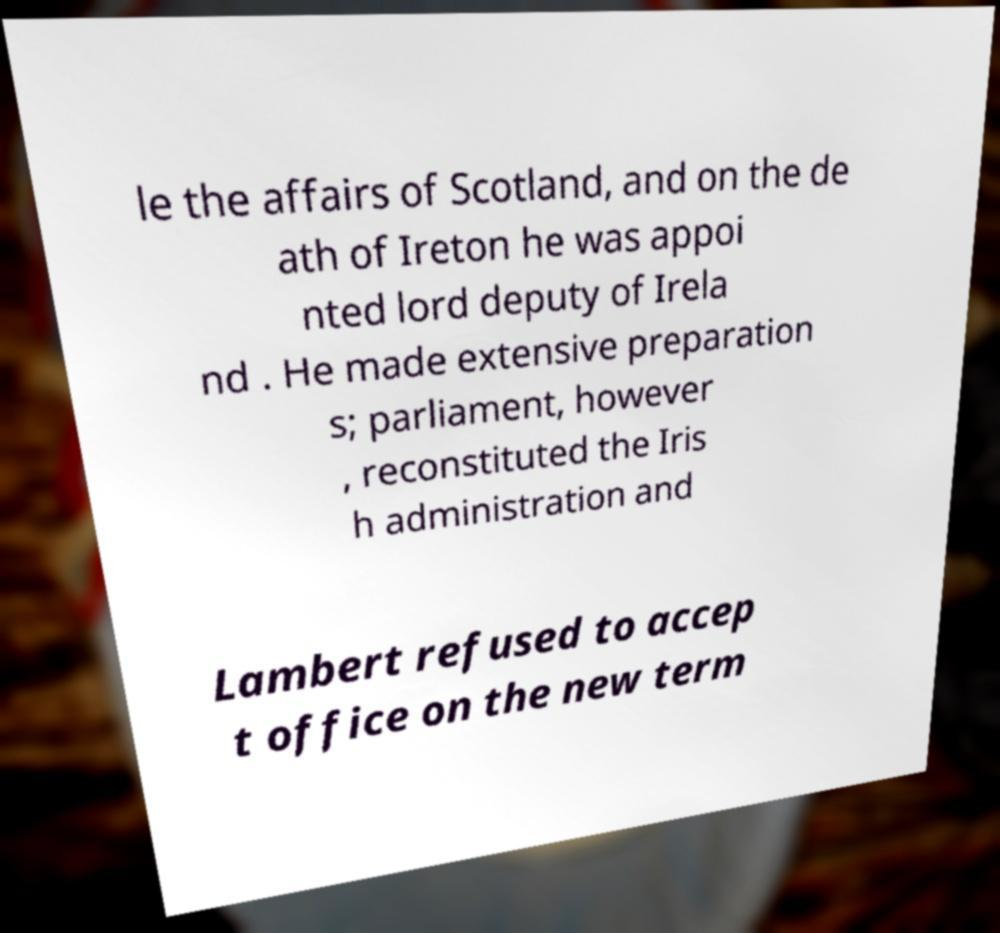There's text embedded in this image that I need extracted. Can you transcribe it verbatim? le the affairs of Scotland, and on the de ath of Ireton he was appoi nted lord deputy of Irela nd . He made extensive preparation s; parliament, however , reconstituted the Iris h administration and Lambert refused to accep t office on the new term 